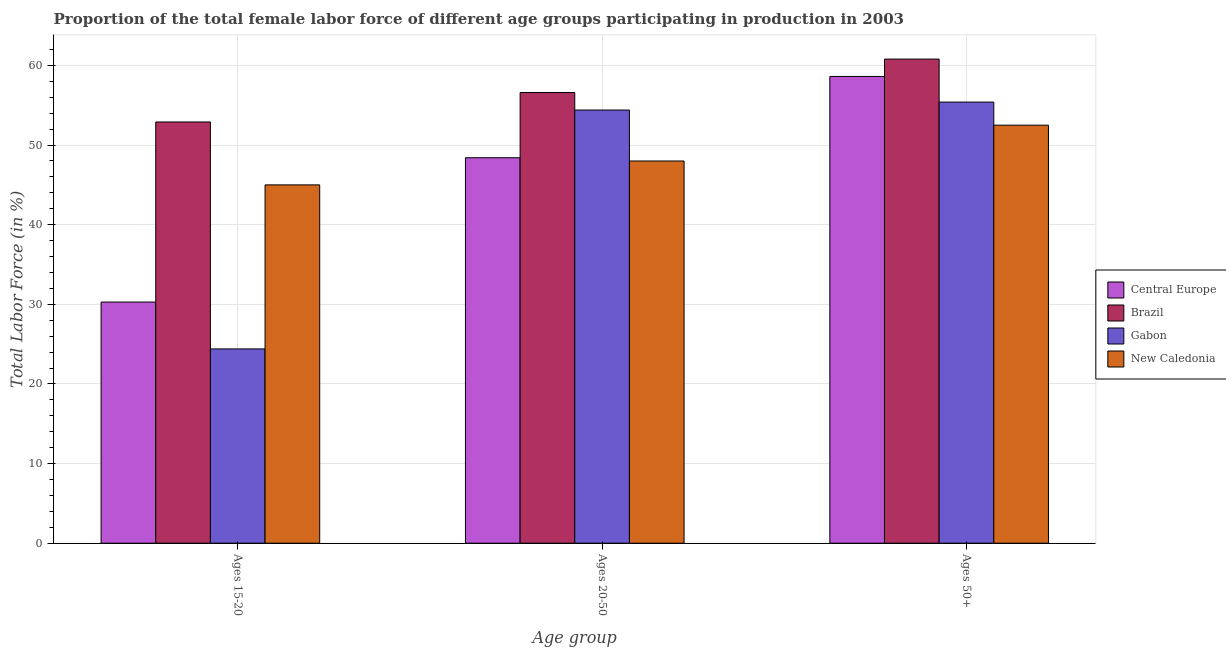How many different coloured bars are there?
Provide a short and direct response. 4. How many groups of bars are there?
Ensure brevity in your answer.  3. Are the number of bars per tick equal to the number of legend labels?
Your response must be concise. Yes. What is the label of the 1st group of bars from the left?
Make the answer very short. Ages 15-20. Across all countries, what is the maximum percentage of female labor force within the age group 15-20?
Provide a short and direct response. 52.9. In which country was the percentage of female labor force above age 50 minimum?
Keep it short and to the point. New Caledonia. What is the total percentage of female labor force within the age group 20-50 in the graph?
Give a very brief answer. 207.41. What is the difference between the percentage of female labor force within the age group 15-20 in New Caledonia and that in Brazil?
Keep it short and to the point. -7.9. What is the difference between the percentage of female labor force within the age group 20-50 in Gabon and the percentage of female labor force above age 50 in New Caledonia?
Your response must be concise. 1.9. What is the average percentage of female labor force above age 50 per country?
Provide a short and direct response. 56.83. What is the ratio of the percentage of female labor force above age 50 in New Caledonia to that in Central Europe?
Make the answer very short. 0.9. Is the percentage of female labor force within the age group 20-50 in Gabon less than that in Brazil?
Give a very brief answer. Yes. Is the difference between the percentage of female labor force within the age group 15-20 in Brazil and New Caledonia greater than the difference between the percentage of female labor force within the age group 20-50 in Brazil and New Caledonia?
Ensure brevity in your answer.  No. What is the difference between the highest and the second highest percentage of female labor force within the age group 20-50?
Your response must be concise. 2.2. What is the difference between the highest and the lowest percentage of female labor force above age 50?
Provide a short and direct response. 8.3. Is the sum of the percentage of female labor force above age 50 in New Caledonia and Central Europe greater than the maximum percentage of female labor force within the age group 15-20 across all countries?
Make the answer very short. Yes. What does the 4th bar from the right in Ages 50+ represents?
Give a very brief answer. Central Europe. How many countries are there in the graph?
Provide a succinct answer. 4. Are the values on the major ticks of Y-axis written in scientific E-notation?
Offer a very short reply. No. Does the graph contain any zero values?
Provide a short and direct response. No. Where does the legend appear in the graph?
Make the answer very short. Center right. How many legend labels are there?
Your answer should be very brief. 4. What is the title of the graph?
Your answer should be compact. Proportion of the total female labor force of different age groups participating in production in 2003. Does "Korea (Democratic)" appear as one of the legend labels in the graph?
Give a very brief answer. No. What is the label or title of the X-axis?
Offer a very short reply. Age group. What is the Total Labor Force (in %) of Central Europe in Ages 15-20?
Give a very brief answer. 30.28. What is the Total Labor Force (in %) in Brazil in Ages 15-20?
Ensure brevity in your answer.  52.9. What is the Total Labor Force (in %) of Gabon in Ages 15-20?
Keep it short and to the point. 24.4. What is the Total Labor Force (in %) of New Caledonia in Ages 15-20?
Your response must be concise. 45. What is the Total Labor Force (in %) in Central Europe in Ages 20-50?
Keep it short and to the point. 48.41. What is the Total Labor Force (in %) in Brazil in Ages 20-50?
Your answer should be very brief. 56.6. What is the Total Labor Force (in %) of Gabon in Ages 20-50?
Make the answer very short. 54.4. What is the Total Labor Force (in %) in Central Europe in Ages 50+?
Offer a very short reply. 58.62. What is the Total Labor Force (in %) in Brazil in Ages 50+?
Ensure brevity in your answer.  60.8. What is the Total Labor Force (in %) in Gabon in Ages 50+?
Give a very brief answer. 55.4. What is the Total Labor Force (in %) of New Caledonia in Ages 50+?
Provide a succinct answer. 52.5. Across all Age group, what is the maximum Total Labor Force (in %) in Central Europe?
Your answer should be very brief. 58.62. Across all Age group, what is the maximum Total Labor Force (in %) in Brazil?
Ensure brevity in your answer.  60.8. Across all Age group, what is the maximum Total Labor Force (in %) in Gabon?
Ensure brevity in your answer.  55.4. Across all Age group, what is the maximum Total Labor Force (in %) of New Caledonia?
Your response must be concise. 52.5. Across all Age group, what is the minimum Total Labor Force (in %) of Central Europe?
Make the answer very short. 30.28. Across all Age group, what is the minimum Total Labor Force (in %) of Brazil?
Offer a very short reply. 52.9. Across all Age group, what is the minimum Total Labor Force (in %) of Gabon?
Provide a succinct answer. 24.4. Across all Age group, what is the minimum Total Labor Force (in %) of New Caledonia?
Ensure brevity in your answer.  45. What is the total Total Labor Force (in %) in Central Europe in the graph?
Your response must be concise. 137.31. What is the total Total Labor Force (in %) of Brazil in the graph?
Offer a very short reply. 170.3. What is the total Total Labor Force (in %) in Gabon in the graph?
Give a very brief answer. 134.2. What is the total Total Labor Force (in %) in New Caledonia in the graph?
Your response must be concise. 145.5. What is the difference between the Total Labor Force (in %) in Central Europe in Ages 15-20 and that in Ages 20-50?
Your answer should be compact. -18.12. What is the difference between the Total Labor Force (in %) of Brazil in Ages 15-20 and that in Ages 20-50?
Ensure brevity in your answer.  -3.7. What is the difference between the Total Labor Force (in %) of New Caledonia in Ages 15-20 and that in Ages 20-50?
Ensure brevity in your answer.  -3. What is the difference between the Total Labor Force (in %) in Central Europe in Ages 15-20 and that in Ages 50+?
Make the answer very short. -28.33. What is the difference between the Total Labor Force (in %) in Gabon in Ages 15-20 and that in Ages 50+?
Your answer should be compact. -31. What is the difference between the Total Labor Force (in %) of Central Europe in Ages 20-50 and that in Ages 50+?
Keep it short and to the point. -10.21. What is the difference between the Total Labor Force (in %) of New Caledonia in Ages 20-50 and that in Ages 50+?
Keep it short and to the point. -4.5. What is the difference between the Total Labor Force (in %) in Central Europe in Ages 15-20 and the Total Labor Force (in %) in Brazil in Ages 20-50?
Your answer should be very brief. -26.32. What is the difference between the Total Labor Force (in %) of Central Europe in Ages 15-20 and the Total Labor Force (in %) of Gabon in Ages 20-50?
Make the answer very short. -24.12. What is the difference between the Total Labor Force (in %) of Central Europe in Ages 15-20 and the Total Labor Force (in %) of New Caledonia in Ages 20-50?
Your response must be concise. -17.72. What is the difference between the Total Labor Force (in %) in Brazil in Ages 15-20 and the Total Labor Force (in %) in Gabon in Ages 20-50?
Make the answer very short. -1.5. What is the difference between the Total Labor Force (in %) of Gabon in Ages 15-20 and the Total Labor Force (in %) of New Caledonia in Ages 20-50?
Provide a short and direct response. -23.6. What is the difference between the Total Labor Force (in %) of Central Europe in Ages 15-20 and the Total Labor Force (in %) of Brazil in Ages 50+?
Make the answer very short. -30.52. What is the difference between the Total Labor Force (in %) in Central Europe in Ages 15-20 and the Total Labor Force (in %) in Gabon in Ages 50+?
Your answer should be very brief. -25.12. What is the difference between the Total Labor Force (in %) in Central Europe in Ages 15-20 and the Total Labor Force (in %) in New Caledonia in Ages 50+?
Offer a very short reply. -22.22. What is the difference between the Total Labor Force (in %) of Brazil in Ages 15-20 and the Total Labor Force (in %) of Gabon in Ages 50+?
Provide a short and direct response. -2.5. What is the difference between the Total Labor Force (in %) in Gabon in Ages 15-20 and the Total Labor Force (in %) in New Caledonia in Ages 50+?
Provide a short and direct response. -28.1. What is the difference between the Total Labor Force (in %) of Central Europe in Ages 20-50 and the Total Labor Force (in %) of Brazil in Ages 50+?
Provide a succinct answer. -12.39. What is the difference between the Total Labor Force (in %) of Central Europe in Ages 20-50 and the Total Labor Force (in %) of Gabon in Ages 50+?
Ensure brevity in your answer.  -6.99. What is the difference between the Total Labor Force (in %) in Central Europe in Ages 20-50 and the Total Labor Force (in %) in New Caledonia in Ages 50+?
Provide a short and direct response. -4.09. What is the difference between the Total Labor Force (in %) of Brazil in Ages 20-50 and the Total Labor Force (in %) of Gabon in Ages 50+?
Keep it short and to the point. 1.2. What is the average Total Labor Force (in %) in Central Europe per Age group?
Provide a short and direct response. 45.77. What is the average Total Labor Force (in %) in Brazil per Age group?
Provide a short and direct response. 56.77. What is the average Total Labor Force (in %) of Gabon per Age group?
Give a very brief answer. 44.73. What is the average Total Labor Force (in %) in New Caledonia per Age group?
Your answer should be very brief. 48.5. What is the difference between the Total Labor Force (in %) in Central Europe and Total Labor Force (in %) in Brazil in Ages 15-20?
Offer a terse response. -22.62. What is the difference between the Total Labor Force (in %) of Central Europe and Total Labor Force (in %) of Gabon in Ages 15-20?
Give a very brief answer. 5.88. What is the difference between the Total Labor Force (in %) of Central Europe and Total Labor Force (in %) of New Caledonia in Ages 15-20?
Provide a succinct answer. -14.72. What is the difference between the Total Labor Force (in %) in Brazil and Total Labor Force (in %) in Gabon in Ages 15-20?
Offer a terse response. 28.5. What is the difference between the Total Labor Force (in %) in Gabon and Total Labor Force (in %) in New Caledonia in Ages 15-20?
Your answer should be compact. -20.6. What is the difference between the Total Labor Force (in %) in Central Europe and Total Labor Force (in %) in Brazil in Ages 20-50?
Your answer should be compact. -8.19. What is the difference between the Total Labor Force (in %) of Central Europe and Total Labor Force (in %) of Gabon in Ages 20-50?
Offer a very short reply. -5.99. What is the difference between the Total Labor Force (in %) in Central Europe and Total Labor Force (in %) in New Caledonia in Ages 20-50?
Ensure brevity in your answer.  0.41. What is the difference between the Total Labor Force (in %) of Brazil and Total Labor Force (in %) of Gabon in Ages 20-50?
Provide a succinct answer. 2.2. What is the difference between the Total Labor Force (in %) in Central Europe and Total Labor Force (in %) in Brazil in Ages 50+?
Offer a terse response. -2.18. What is the difference between the Total Labor Force (in %) of Central Europe and Total Labor Force (in %) of Gabon in Ages 50+?
Provide a succinct answer. 3.22. What is the difference between the Total Labor Force (in %) in Central Europe and Total Labor Force (in %) in New Caledonia in Ages 50+?
Provide a succinct answer. 6.12. What is the difference between the Total Labor Force (in %) of Brazil and Total Labor Force (in %) of New Caledonia in Ages 50+?
Your response must be concise. 8.3. What is the ratio of the Total Labor Force (in %) of Central Europe in Ages 15-20 to that in Ages 20-50?
Provide a short and direct response. 0.63. What is the ratio of the Total Labor Force (in %) of Brazil in Ages 15-20 to that in Ages 20-50?
Provide a succinct answer. 0.93. What is the ratio of the Total Labor Force (in %) of Gabon in Ages 15-20 to that in Ages 20-50?
Provide a succinct answer. 0.45. What is the ratio of the Total Labor Force (in %) of Central Europe in Ages 15-20 to that in Ages 50+?
Offer a very short reply. 0.52. What is the ratio of the Total Labor Force (in %) in Brazil in Ages 15-20 to that in Ages 50+?
Keep it short and to the point. 0.87. What is the ratio of the Total Labor Force (in %) of Gabon in Ages 15-20 to that in Ages 50+?
Provide a succinct answer. 0.44. What is the ratio of the Total Labor Force (in %) in New Caledonia in Ages 15-20 to that in Ages 50+?
Make the answer very short. 0.86. What is the ratio of the Total Labor Force (in %) in Central Europe in Ages 20-50 to that in Ages 50+?
Provide a short and direct response. 0.83. What is the ratio of the Total Labor Force (in %) of Brazil in Ages 20-50 to that in Ages 50+?
Offer a terse response. 0.93. What is the ratio of the Total Labor Force (in %) in Gabon in Ages 20-50 to that in Ages 50+?
Provide a short and direct response. 0.98. What is the ratio of the Total Labor Force (in %) of New Caledonia in Ages 20-50 to that in Ages 50+?
Make the answer very short. 0.91. What is the difference between the highest and the second highest Total Labor Force (in %) in Central Europe?
Make the answer very short. 10.21. What is the difference between the highest and the second highest Total Labor Force (in %) of Gabon?
Your answer should be compact. 1. What is the difference between the highest and the lowest Total Labor Force (in %) in Central Europe?
Offer a very short reply. 28.33. What is the difference between the highest and the lowest Total Labor Force (in %) of Brazil?
Offer a terse response. 7.9. What is the difference between the highest and the lowest Total Labor Force (in %) of New Caledonia?
Your answer should be compact. 7.5. 